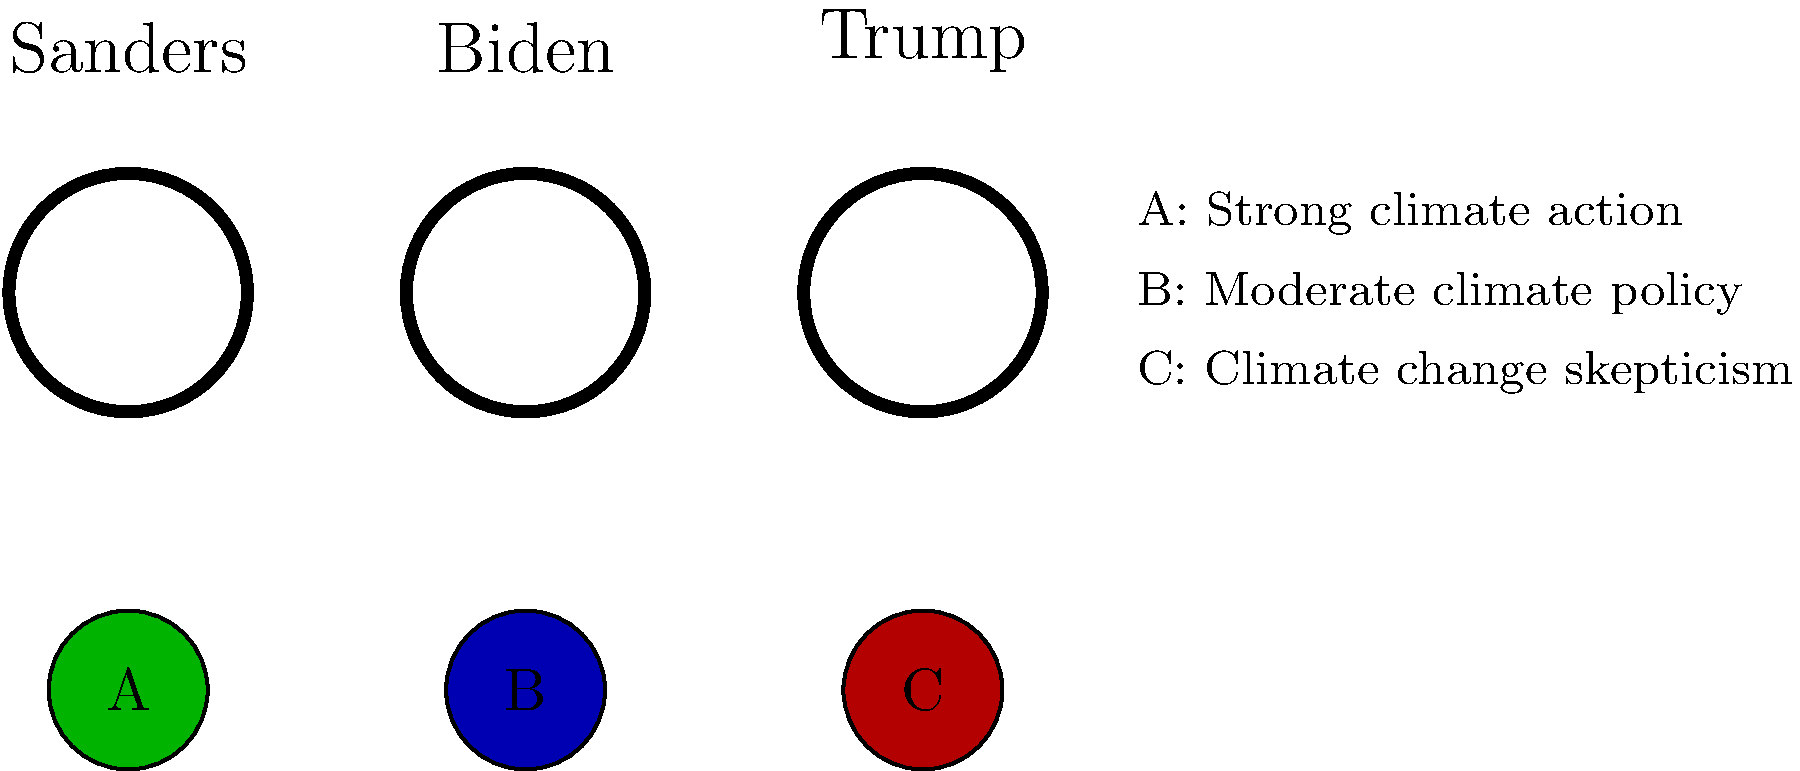Match each US politician to their most closely associated environmental policy position by connecting their headshot to the corresponding policy icon. 1. Bernie Sanders is known for his strong advocacy for climate action and environmental protection. He has proposed ambitious plans like the Green New Deal, which aims for rapid decarbonization of the economy. This aligns most closely with policy icon A, representing strong climate action.

2. Joe Biden has taken a more moderate stance on climate change compared to Sanders. While he acknowledges the need for action, his policies are generally less aggressive and more incremental. This aligns most closely with policy icon B, representing moderate climate policy.

3. Donald Trump has expressed skepticism about climate change and its causes. During his presidency, he withdrew the US from the Paris Agreement and rolled back various environmental regulations. This aligns most closely with policy icon C, representing climate change skepticism.

Therefore, the correct matching is:
Sanders - A (Strong climate action)
Biden - B (Moderate climate policy)
Trump - C (Climate change skepticism)
Answer: Sanders-A, Biden-B, Trump-C 